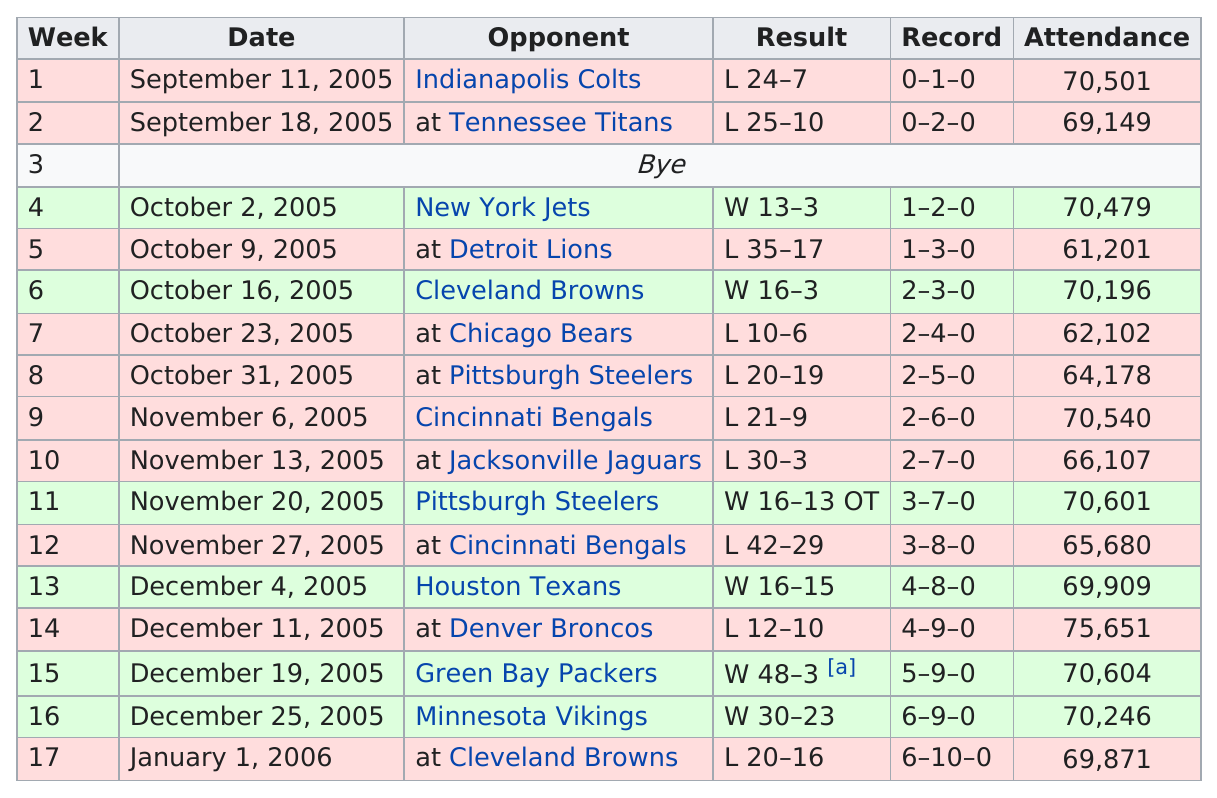Indicate a few pertinent items in this graphic. The Ravens triumphed in week 13, winning by a decisive margin of 1 point. What game had the most attendees on December 11, 2005? On December 19, 2005, the game with the largest difference in score was played. The attendance difference between the first game in September and the last game in January is 630. The total number of points scored is 564. 